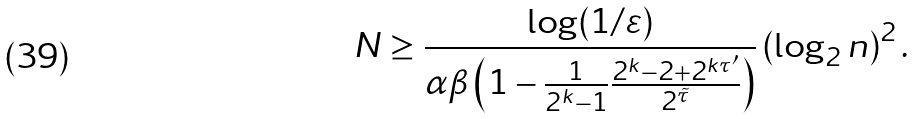<formula> <loc_0><loc_0><loc_500><loc_500>N \geq \frac { \log ( 1 / \varepsilon ) } { \alpha \beta \left ( 1 - \frac { 1 } { 2 ^ { k } - 1 } \frac { 2 ^ { k } - 2 + 2 ^ { k \tau ^ { \prime } } } { 2 ^ { \tilde { \tau } } } \right ) } \left ( \log _ { 2 } n \right ) ^ { 2 } .</formula> 